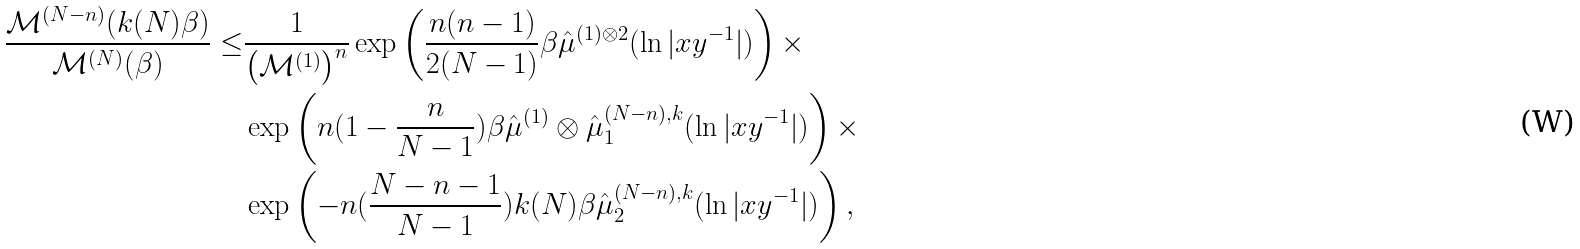<formula> <loc_0><loc_0><loc_500><loc_500>\frac { \mathcal { M } ^ { ( N - n ) } ( k ( N ) \beta ) } { \mathcal { M } ^ { ( N ) } ( \beta ) } \leq & \frac { 1 } { \left ( \mathcal { M } ^ { ( 1 ) } \right ) ^ { n } } \exp \left ( \frac { n ( n - 1 ) } { 2 ( N - 1 ) } \beta \hat { \mu } ^ { ( 1 ) \otimes 2 } ( \ln | x y ^ { - 1 } | ) \right ) \times \\ & \exp \left ( n ( 1 - \frac { n } { N - 1 } ) \beta \hat { \mu } ^ { ( 1 ) } \otimes \hat { \mu } _ { 1 } ^ { ( N - n ) , k } ( \ln | x y ^ { - 1 } | ) \right ) \times \\ & \exp \left ( - n ( \frac { N - n - 1 } { N - 1 } ) k ( N ) \beta \hat { \mu } _ { 2 } ^ { ( N - n ) , k } ( \ln | x y ^ { - 1 } | ) \right ) ,</formula> 